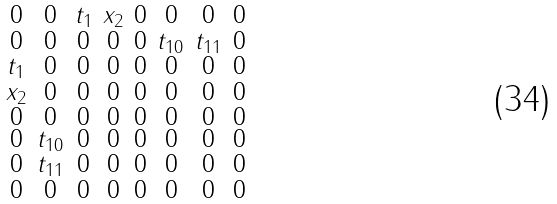<formula> <loc_0><loc_0><loc_500><loc_500>\begin{smallmatrix} 0 & 0 & { t _ { 1 } } & { x _ { 2 } } & 0 & 0 & 0 & 0 \\ 0 & 0 & 0 & 0 & 0 & { t _ { 1 0 } } & { t _ { 1 1 } } & 0 \\ { t _ { 1 } } & 0 & 0 & 0 & 0 & 0 & 0 & 0 \\ { x _ { 2 } } & 0 & 0 & 0 & 0 & 0 & 0 & 0 \\ 0 & 0 & 0 & 0 & 0 & 0 & 0 & 0 \\ 0 & { t _ { 1 0 } } & 0 & 0 & 0 & 0 & 0 & 0 \\ 0 & { t _ { 1 1 } } & 0 & 0 & 0 & 0 & 0 & 0 \\ 0 & 0 & 0 & 0 & 0 & 0 & 0 & 0 \end{smallmatrix}</formula> 